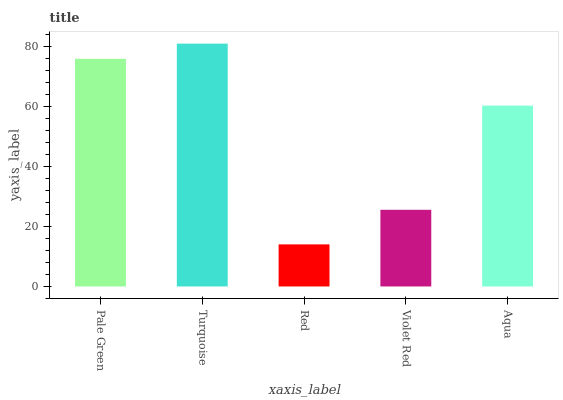Is Turquoise the minimum?
Answer yes or no. No. Is Red the maximum?
Answer yes or no. No. Is Turquoise greater than Red?
Answer yes or no. Yes. Is Red less than Turquoise?
Answer yes or no. Yes. Is Red greater than Turquoise?
Answer yes or no. No. Is Turquoise less than Red?
Answer yes or no. No. Is Aqua the high median?
Answer yes or no. Yes. Is Aqua the low median?
Answer yes or no. Yes. Is Red the high median?
Answer yes or no. No. Is Red the low median?
Answer yes or no. No. 